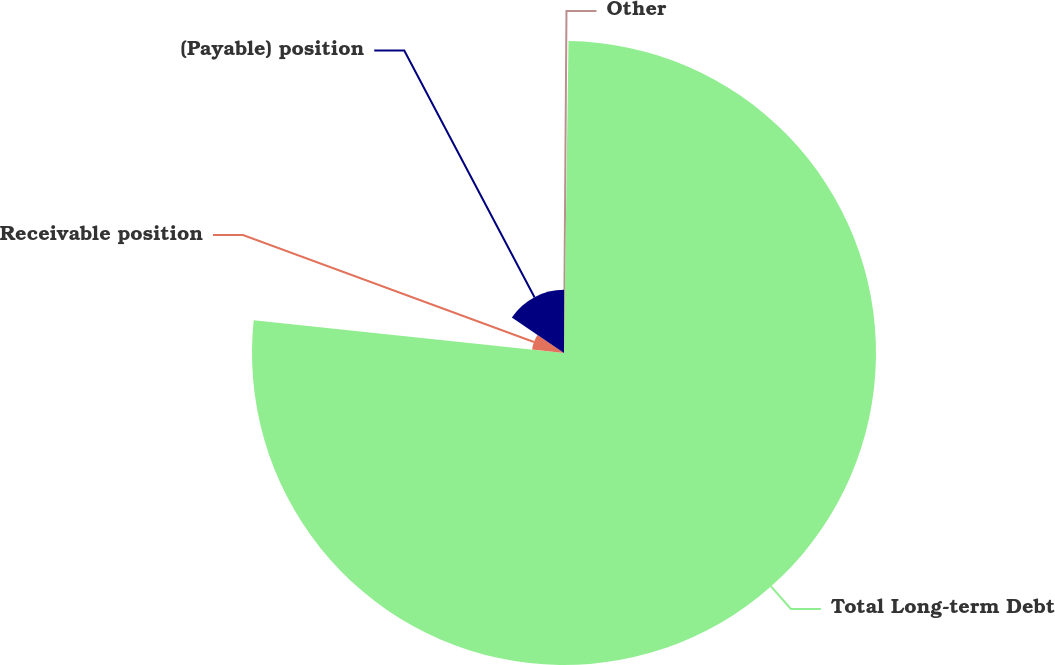Convert chart. <chart><loc_0><loc_0><loc_500><loc_500><pie_chart><fcel>Other<fcel>Total Long-term Debt<fcel>Receivable position<fcel>(Payable) position<nl><fcel>0.23%<fcel>76.45%<fcel>7.85%<fcel>15.47%<nl></chart> 